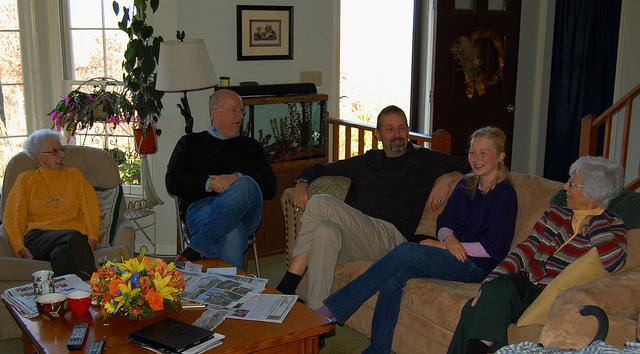What kind of pants is the man wearing?
Write a very short answer. Khaki. What color are the flowers on the table?
Give a very brief answer. Yellow. Is this picture completely indoors?
Concise answer only. Yes. How many people are there?
Answer briefly. 5. Is this a press conference?
Answer briefly. No. Are the ladies on the right wearing the same color?
Answer briefly. No. What is on the table?
Concise answer only. Flowers. Are they having lunch?
Keep it brief. No. How many plants?
Give a very brief answer. 3. How many people are in the room?
Quick response, please. 5. Are any of these people in costume?
Short answer required. No. Is the image black and white?
Write a very short answer. No. What is the blonde woman wearing on her legs?
Give a very brief answer. Jeans. Is the lamp on?
Quick response, please. No. What color is the chair?
Be succinct. Tan. What is on the wall?
Write a very short answer. Picture. How many people are standing?
Give a very brief answer. 0. What color is her shirt?
Be succinct. Blue. Is this a coffee shop?
Quick response, please. No. Are these men soldiers?
Write a very short answer. No. Is this someone's home?
Write a very short answer. Yes. Is this indoors?
Give a very brief answer. Yes. What room is this?
Answer briefly. Living room. Would this be an antique shop?
Concise answer only. No. What kind of fruit can you see?
Answer briefly. None. What shows that these people are cold?
Keep it brief. Sweaters. Are they playing guitars?
Keep it brief. No. How many people are taking pictures?
Short answer required. 1. Is this a dining room?
Short answer required. No. How many people are in the photo?
Be succinct. 5. Where is this?
Quick response, please. Living room. How many fingers does grandma on the far left have showing?
Concise answer only. 0. 